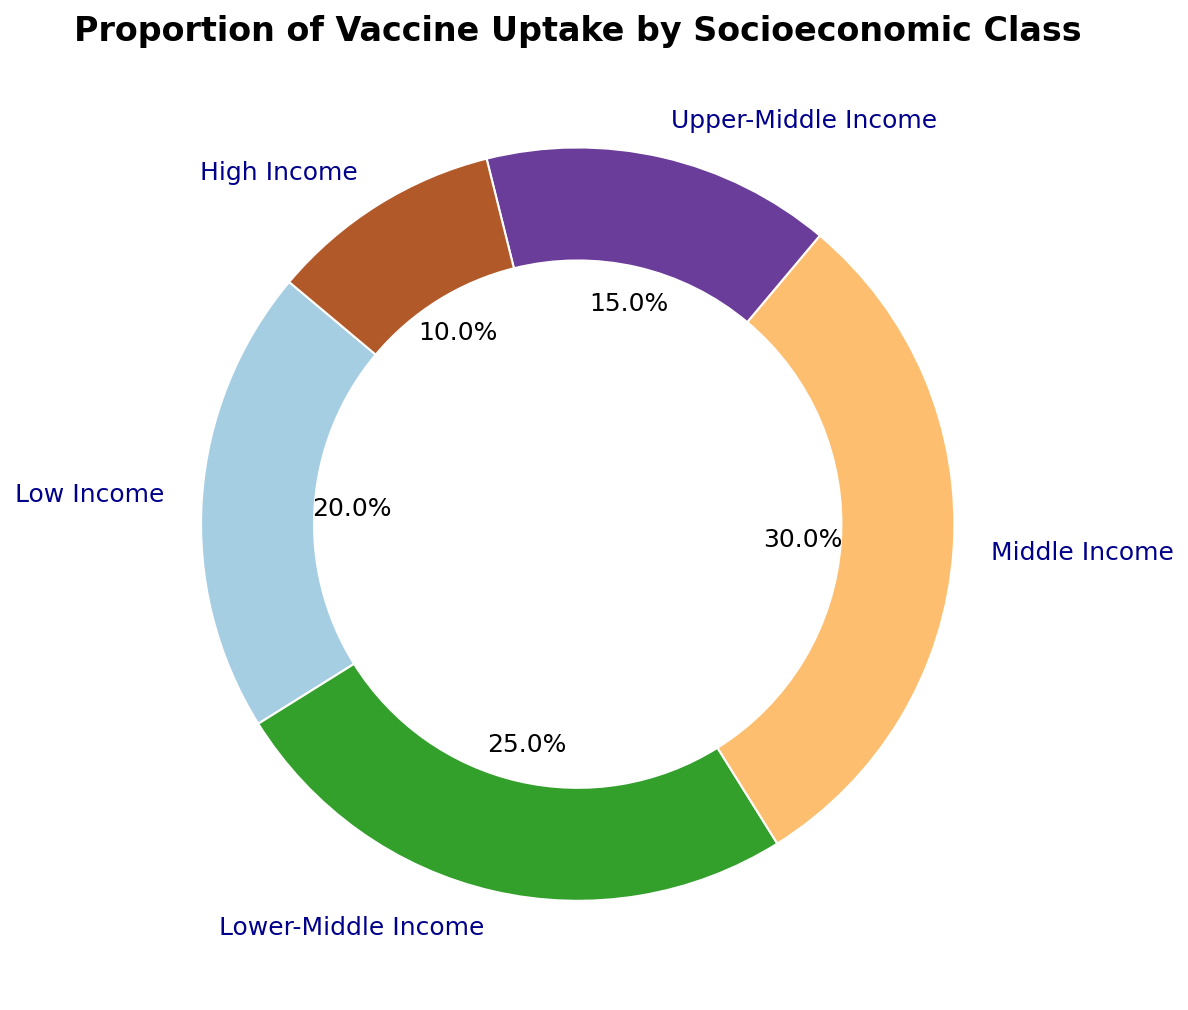What proportion of the vaccine uptake is from the Middle Income group? The section labeled "Middle Income" in the pie chart shows that it accounts for 30% of the vaccine uptake.
Answer: 30% Which socioeconomic class has the highest proportion of vaccine uptake? The segment with the largest size in the pie chart belongs to the "Middle Income" class, indicating it has the highest proportion at 30%.
Answer: Middle Income Which socioeconomic class has the lowest proportion of vaccine uptake? The smallest segment in the pie chart corresponds to the "High Income" class, which accounts for 10% of the vaccine uptake.
Answer: High Income How much larger is the proportion of vaccine uptake in the Lower-Middle Income group compared to the High Income group? The proportion of the Lower-Middle Income group is 25%, and the High Income group is 10%. The difference is 25% - 10% = 15%.
Answer: 15% What is the combined proportion of vaccine uptake in the Low Income and Upper-Middle Income groups? The Low Income group has 20% and the Upper-Middle Income group has 15%. The combined proportion is 20% + 15% = 35%.
Answer: 35% Which two socioeconomic classes have a combined proportion of 45%? Calculating the sum of different class proportions: Low Income (20%) + Lower-Middle Income (25%) = 45%; Middle Income (30%) + Upper-Middle Income (15%) = 45%. Both combinations are correct, i.e., Low Income + Lower-Middle Income and Middle Income + Upper-Middle Income.
Answer: Low Income + Lower-Middle Income, Middle Income + Upper-Middle Income Rank the socioeconomic classes from highest to lowest in terms of vaccine uptake proportions. By looking at the pie chart's segments from largest to smallest, the ranking is: Middle Income (30%), Lower-Middle Income (25%), Low Income (20%), Upper-Middle Income (15%), High Income (10%).
Answer: Middle Income > Lower-Middle Income > Low Income > Upper-Middle Income > High Income If 1000 people were vaccinated, how many belong to the Lower-Middle Income class? The pie chart shows the Lower-Middle Income class at 25%. 25% of 1000 people is calculated as (25/100) * 1000 = 250.
Answer: 250 people What percentage of the population from the Low Income and Middle Income classes together got vaccinated? The Low Income class accounts for 20% and Middle Income for 30%. Together these classes account for 20% + 30% = 50%.
Answer: 50% If another socioeconomic class was added to the pie chart, making the total now 6 classes, how would you expect the relative proportions of each class to change assuming the total vaccinated population remains the same? Without specific data on the new class's proportion, it's assumed the existing proportions would slightly decrease to accommodate the new class, while still summing up to 100%.
Answer: Proportions would decrease slightly 